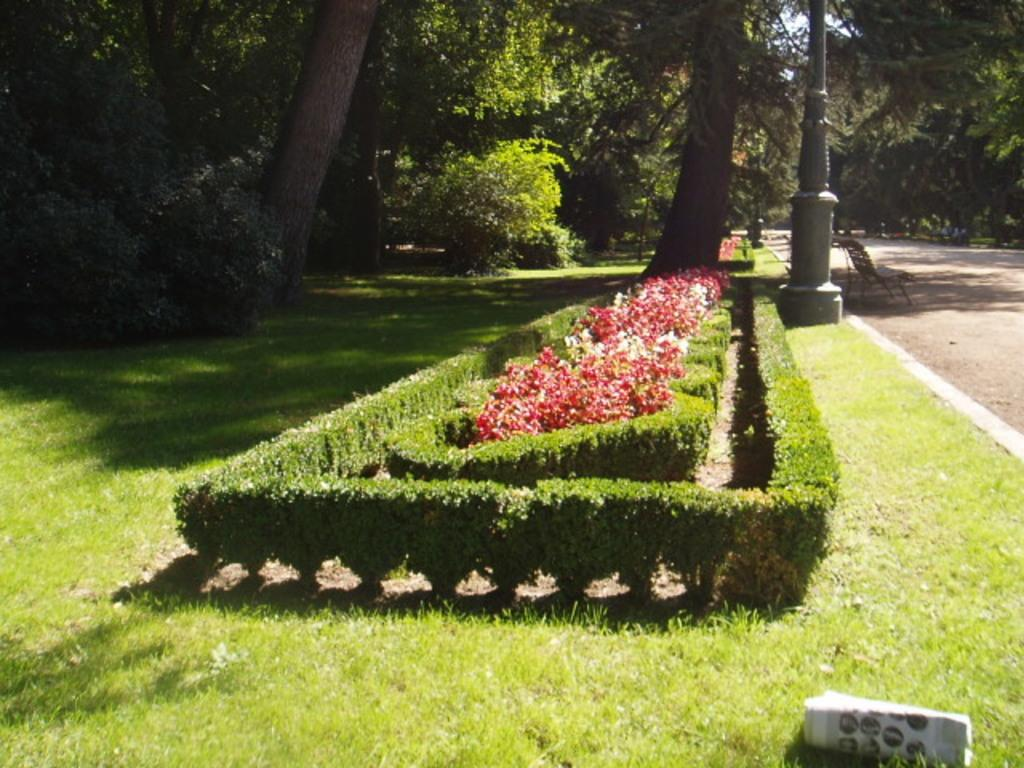What is the main subject in the foreground of the picture? There is a garden in the foreground of the picture. What is the location of the garden in relation to other elements in the image? The garden is located near a road. What types of vegetation can be seen in the garden? There are trees and plants present in the garden. What additional object can be seen in the garden? There is a paper visible in the garden. Is there any furniture in the garden? Yes, there is a chair in the garden. How is the coat being measured in the garden? There is no coat present in the image, so it cannot be measured. 